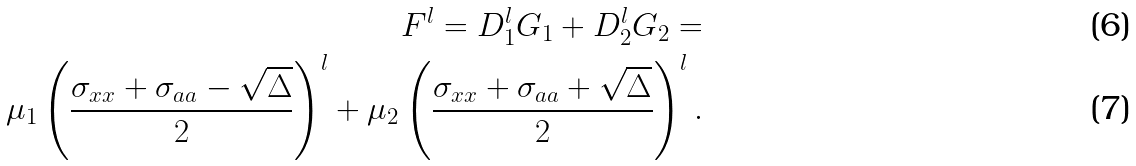Convert formula to latex. <formula><loc_0><loc_0><loc_500><loc_500>F ^ { l } = D _ { 1 } ^ { l } G _ { 1 } + D _ { 2 } ^ { l } G _ { 2 } = \\ \mu _ { 1 } \left ( \frac { \sigma _ { x x } + \sigma _ { a a } - \sqrt { \Delta } } { 2 } \right ) ^ { l } + \mu _ { 2 } \left ( \frac { \sigma _ { x x } + \sigma _ { a a } + \sqrt { \Delta } } { 2 } \right ) ^ { l } .</formula> 